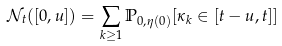<formula> <loc_0><loc_0><loc_500><loc_500>{ \mathcal { N } } _ { t } ( [ 0 , u ] ) = \sum _ { k \geq 1 } { \mathbb { P } } _ { 0 , \eta ( 0 ) } [ \kappa _ { k } \in [ t - u , t ] ]</formula> 